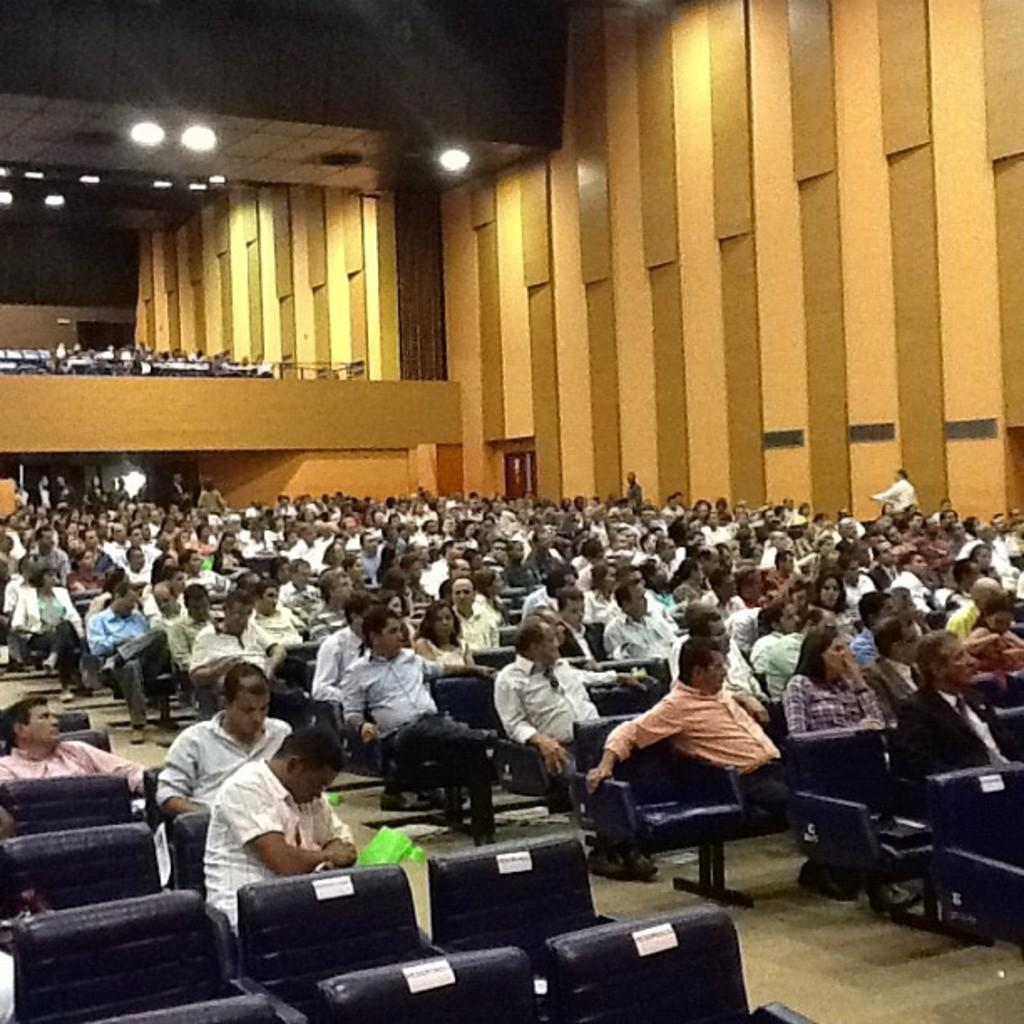What type of furniture is visible in the image? There are chairs in the image. What can be seen illuminating the area in the image? There are lights in the image. What is the surface that people are standing or walking on in the image? The floor is visible in the image. What else can be seen in the image besides the chairs and lights? There are objects and a door in the image. What are the people in the image doing? People are sitting on the chairs. Are there any decorations or additional features on the chairs? Stickers are present on some chairs. What time is it according to the hour displayed on the wall in the image? There is no hour displayed on the wall in the image. How many people are in the crowd gathered around the chairs in the image? There is no crowd present in the image; only people sitting on the chairs can be seen. What tool is being used to fix the door in the image? There is no tool being used to fix the door in the image, and no wrench is present. 